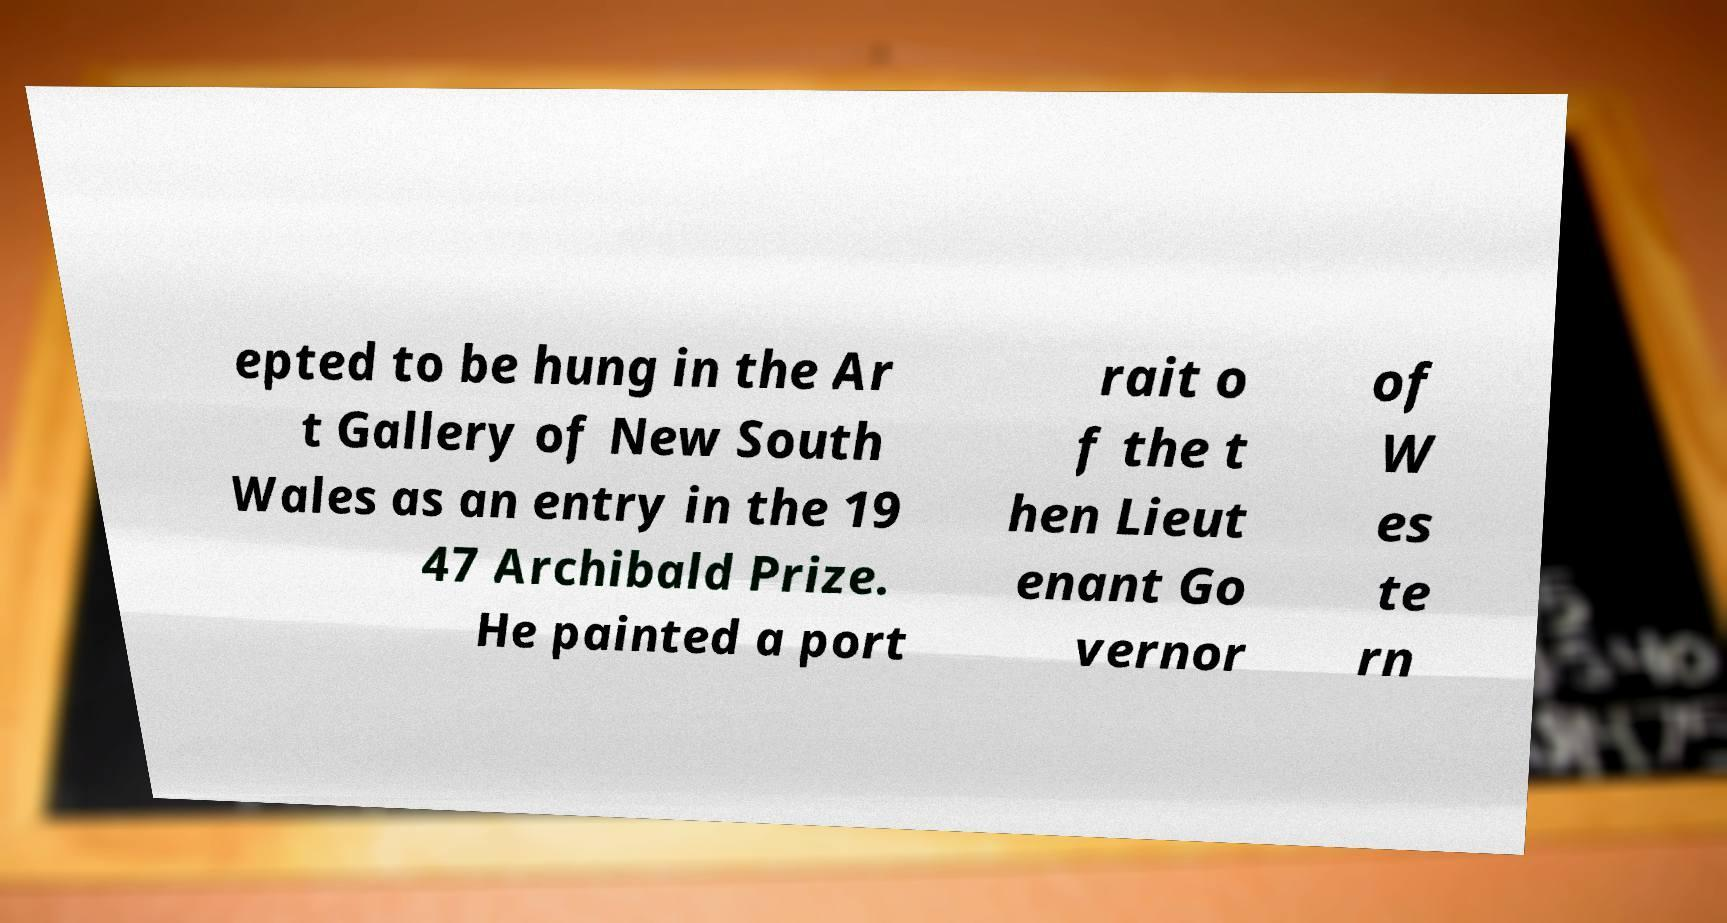Please read and relay the text visible in this image. What does it say? epted to be hung in the Ar t Gallery of New South Wales as an entry in the 19 47 Archibald Prize. He painted a port rait o f the t hen Lieut enant Go vernor of W es te rn 